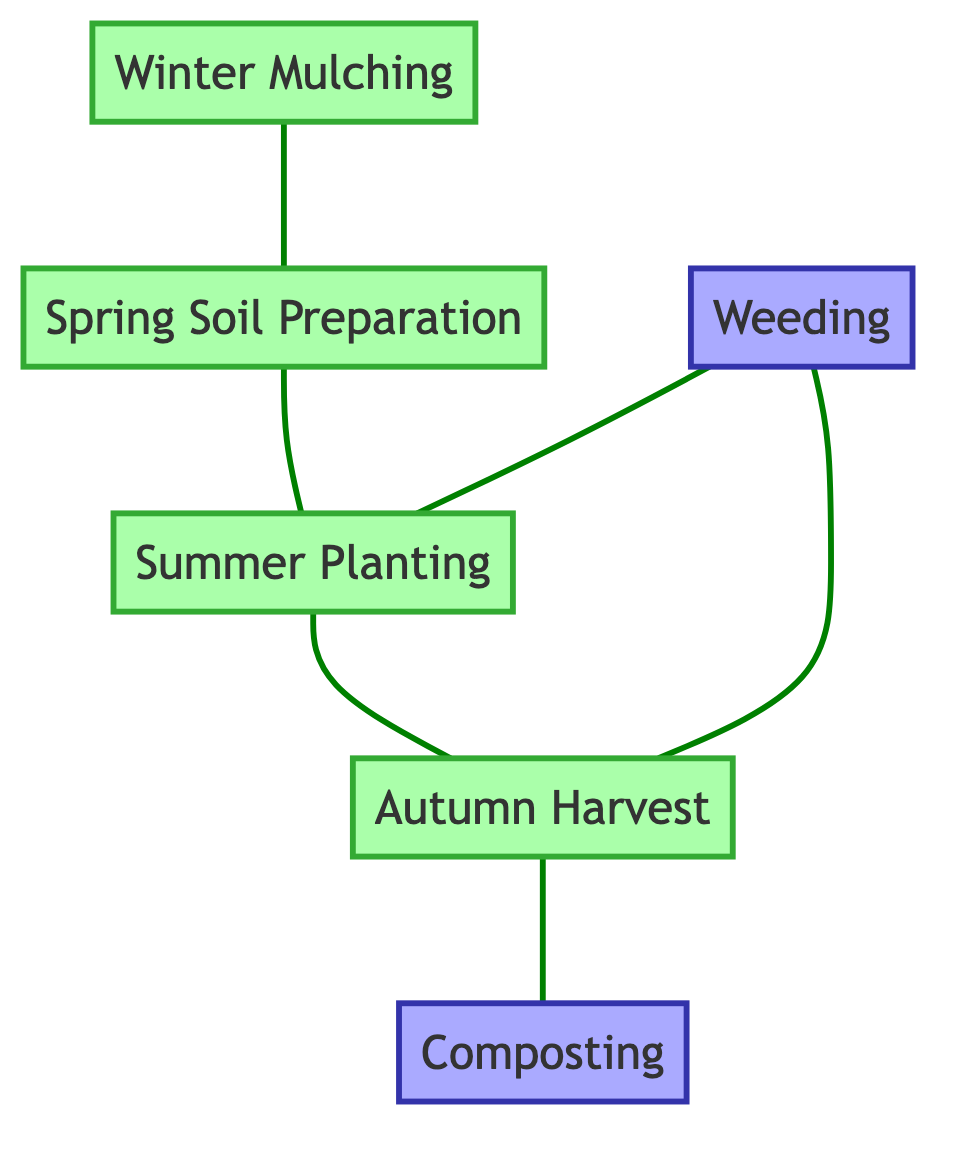What is the first task in the seasonal gardening process? The first task is "Spring Soil Preparation," as it is at the beginning of the diagram and leads to "Summer Planting."
Answer: Spring Soil Preparation How many tasks are represented in the diagram? There are six tasks represented in the diagram. These include "Spring Soil Preparation," "Summer Planting," "Autumn Harvest," "Winter Mulching," "Composting," and "Weeding."
Answer: 6 Which task follows "Summer Planting"? The task that follows "Summer Planting" is "Autumn Harvest," as indicated by the connecting edge in the diagram.
Answer: Autumn Harvest From which season does "Winter Mulching" lead back to begin the gardening tasks again? "Winter Mulching" leads back to "Spring Soil Preparation," signaling the start of the gardening tasks over again.
Answer: Spring Soil Preparation Which two tasks are dependent on "Weeding"? "Summer Planting" and "Autumn Harvest" are dependent on "Weeding," as shown by their connections in the diagram.
Answer: Summer Planting, Autumn Harvest What task is completed after "Autumn Harvest"? The task that is completed after "Autumn Harvest" is "Composting," according to the directed sequence in the diagram.
Answer: Composting Which task directly follows "Autumn Harvest"? The task directly following "Autumn Harvest" is "Composting," shown by the direct connection between the two in the diagram.
Answer: Composting What type of graph is represented here? The diagram represents an undirected graph since it shows connections between tasks without a directional flow.
Answer: Undirected Graph 